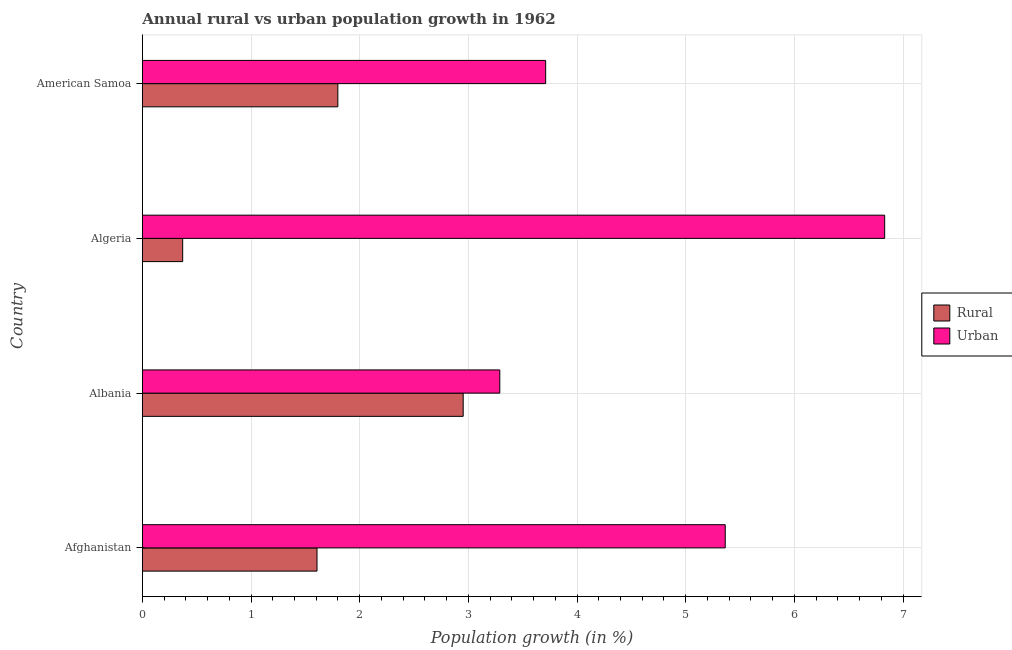How many groups of bars are there?
Provide a succinct answer. 4. What is the label of the 3rd group of bars from the top?
Your response must be concise. Albania. In how many cases, is the number of bars for a given country not equal to the number of legend labels?
Provide a succinct answer. 0. What is the urban population growth in American Samoa?
Ensure brevity in your answer.  3.71. Across all countries, what is the maximum rural population growth?
Give a very brief answer. 2.95. Across all countries, what is the minimum urban population growth?
Give a very brief answer. 3.29. In which country was the urban population growth maximum?
Ensure brevity in your answer.  Algeria. In which country was the rural population growth minimum?
Your response must be concise. Algeria. What is the total rural population growth in the graph?
Your answer should be very brief. 6.73. What is the difference between the rural population growth in Albania and that in Algeria?
Keep it short and to the point. 2.58. What is the difference between the rural population growth in Albania and the urban population growth in Afghanistan?
Keep it short and to the point. -2.41. What is the average rural population growth per country?
Ensure brevity in your answer.  1.68. What is the difference between the rural population growth and urban population growth in Afghanistan?
Your response must be concise. -3.76. In how many countries, is the rural population growth greater than 1.4 %?
Your answer should be very brief. 3. What is the ratio of the rural population growth in Afghanistan to that in American Samoa?
Ensure brevity in your answer.  0.89. Is the urban population growth in Albania less than that in American Samoa?
Keep it short and to the point. Yes. Is the difference between the urban population growth in Albania and American Samoa greater than the difference between the rural population growth in Albania and American Samoa?
Offer a terse response. No. What is the difference between the highest and the second highest urban population growth?
Ensure brevity in your answer.  1.47. What is the difference between the highest and the lowest urban population growth?
Offer a very short reply. 3.54. What does the 1st bar from the top in Algeria represents?
Provide a short and direct response. Urban . What does the 2nd bar from the bottom in American Samoa represents?
Provide a succinct answer. Urban . How many countries are there in the graph?
Your answer should be compact. 4. What is the difference between two consecutive major ticks on the X-axis?
Ensure brevity in your answer.  1. Are the values on the major ticks of X-axis written in scientific E-notation?
Provide a short and direct response. No. Does the graph contain any zero values?
Your answer should be compact. No. How many legend labels are there?
Offer a very short reply. 2. How are the legend labels stacked?
Your response must be concise. Vertical. What is the title of the graph?
Your answer should be very brief. Annual rural vs urban population growth in 1962. Does "Foreign liabilities" appear as one of the legend labels in the graph?
Provide a succinct answer. No. What is the label or title of the X-axis?
Your answer should be very brief. Population growth (in %). What is the label or title of the Y-axis?
Give a very brief answer. Country. What is the Population growth (in %) in Rural in Afghanistan?
Your answer should be very brief. 1.61. What is the Population growth (in %) in Urban  in Afghanistan?
Offer a very short reply. 5.36. What is the Population growth (in %) in Rural in Albania?
Keep it short and to the point. 2.95. What is the Population growth (in %) in Urban  in Albania?
Your answer should be compact. 3.29. What is the Population growth (in %) in Rural in Algeria?
Make the answer very short. 0.37. What is the Population growth (in %) of Urban  in Algeria?
Give a very brief answer. 6.83. What is the Population growth (in %) in Rural in American Samoa?
Provide a succinct answer. 1.8. What is the Population growth (in %) of Urban  in American Samoa?
Your answer should be very brief. 3.71. Across all countries, what is the maximum Population growth (in %) in Rural?
Provide a succinct answer. 2.95. Across all countries, what is the maximum Population growth (in %) in Urban ?
Offer a very short reply. 6.83. Across all countries, what is the minimum Population growth (in %) of Rural?
Offer a very short reply. 0.37. Across all countries, what is the minimum Population growth (in %) of Urban ?
Offer a terse response. 3.29. What is the total Population growth (in %) in Rural in the graph?
Make the answer very short. 6.73. What is the total Population growth (in %) of Urban  in the graph?
Make the answer very short. 19.19. What is the difference between the Population growth (in %) of Rural in Afghanistan and that in Albania?
Ensure brevity in your answer.  -1.35. What is the difference between the Population growth (in %) of Urban  in Afghanistan and that in Albania?
Provide a succinct answer. 2.07. What is the difference between the Population growth (in %) of Rural in Afghanistan and that in Algeria?
Offer a terse response. 1.24. What is the difference between the Population growth (in %) of Urban  in Afghanistan and that in Algeria?
Your response must be concise. -1.47. What is the difference between the Population growth (in %) in Rural in Afghanistan and that in American Samoa?
Ensure brevity in your answer.  -0.19. What is the difference between the Population growth (in %) of Urban  in Afghanistan and that in American Samoa?
Your answer should be compact. 1.65. What is the difference between the Population growth (in %) in Rural in Albania and that in Algeria?
Ensure brevity in your answer.  2.58. What is the difference between the Population growth (in %) of Urban  in Albania and that in Algeria?
Your answer should be very brief. -3.54. What is the difference between the Population growth (in %) in Rural in Albania and that in American Samoa?
Provide a short and direct response. 1.15. What is the difference between the Population growth (in %) in Urban  in Albania and that in American Samoa?
Your answer should be compact. -0.42. What is the difference between the Population growth (in %) in Rural in Algeria and that in American Samoa?
Provide a succinct answer. -1.43. What is the difference between the Population growth (in %) in Urban  in Algeria and that in American Samoa?
Your answer should be compact. 3.12. What is the difference between the Population growth (in %) in Rural in Afghanistan and the Population growth (in %) in Urban  in Albania?
Keep it short and to the point. -1.68. What is the difference between the Population growth (in %) of Rural in Afghanistan and the Population growth (in %) of Urban  in Algeria?
Provide a succinct answer. -5.22. What is the difference between the Population growth (in %) of Rural in Afghanistan and the Population growth (in %) of Urban  in American Samoa?
Offer a very short reply. -2.1. What is the difference between the Population growth (in %) of Rural in Albania and the Population growth (in %) of Urban  in Algeria?
Offer a very short reply. -3.88. What is the difference between the Population growth (in %) of Rural in Albania and the Population growth (in %) of Urban  in American Samoa?
Your answer should be very brief. -0.76. What is the difference between the Population growth (in %) in Rural in Algeria and the Population growth (in %) in Urban  in American Samoa?
Give a very brief answer. -3.34. What is the average Population growth (in %) in Rural per country?
Ensure brevity in your answer.  1.68. What is the average Population growth (in %) of Urban  per country?
Offer a very short reply. 4.8. What is the difference between the Population growth (in %) of Rural and Population growth (in %) of Urban  in Afghanistan?
Make the answer very short. -3.76. What is the difference between the Population growth (in %) in Rural and Population growth (in %) in Urban  in Albania?
Give a very brief answer. -0.34. What is the difference between the Population growth (in %) of Rural and Population growth (in %) of Urban  in Algeria?
Provide a short and direct response. -6.46. What is the difference between the Population growth (in %) of Rural and Population growth (in %) of Urban  in American Samoa?
Ensure brevity in your answer.  -1.91. What is the ratio of the Population growth (in %) in Rural in Afghanistan to that in Albania?
Your answer should be compact. 0.54. What is the ratio of the Population growth (in %) of Urban  in Afghanistan to that in Albania?
Offer a terse response. 1.63. What is the ratio of the Population growth (in %) in Rural in Afghanistan to that in Algeria?
Your answer should be very brief. 4.33. What is the ratio of the Population growth (in %) of Urban  in Afghanistan to that in Algeria?
Your response must be concise. 0.79. What is the ratio of the Population growth (in %) of Rural in Afghanistan to that in American Samoa?
Your answer should be very brief. 0.89. What is the ratio of the Population growth (in %) in Urban  in Afghanistan to that in American Samoa?
Provide a succinct answer. 1.45. What is the ratio of the Population growth (in %) in Rural in Albania to that in Algeria?
Offer a terse response. 7.95. What is the ratio of the Population growth (in %) of Urban  in Albania to that in Algeria?
Your answer should be very brief. 0.48. What is the ratio of the Population growth (in %) of Rural in Albania to that in American Samoa?
Ensure brevity in your answer.  1.64. What is the ratio of the Population growth (in %) in Urban  in Albania to that in American Samoa?
Give a very brief answer. 0.89. What is the ratio of the Population growth (in %) of Rural in Algeria to that in American Samoa?
Make the answer very short. 0.21. What is the ratio of the Population growth (in %) in Urban  in Algeria to that in American Samoa?
Offer a very short reply. 1.84. What is the difference between the highest and the second highest Population growth (in %) of Rural?
Offer a terse response. 1.15. What is the difference between the highest and the second highest Population growth (in %) of Urban ?
Your response must be concise. 1.47. What is the difference between the highest and the lowest Population growth (in %) in Rural?
Offer a very short reply. 2.58. What is the difference between the highest and the lowest Population growth (in %) of Urban ?
Your answer should be compact. 3.54. 